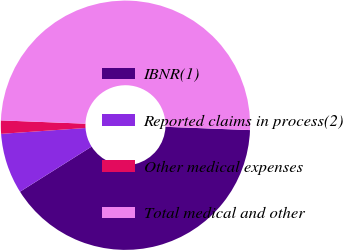<chart> <loc_0><loc_0><loc_500><loc_500><pie_chart><fcel>IBNR(1)<fcel>Reported claims in process(2)<fcel>Other medical expenses<fcel>Total medical and other<nl><fcel>40.43%<fcel>7.85%<fcel>1.72%<fcel>50.0%<nl></chart> 